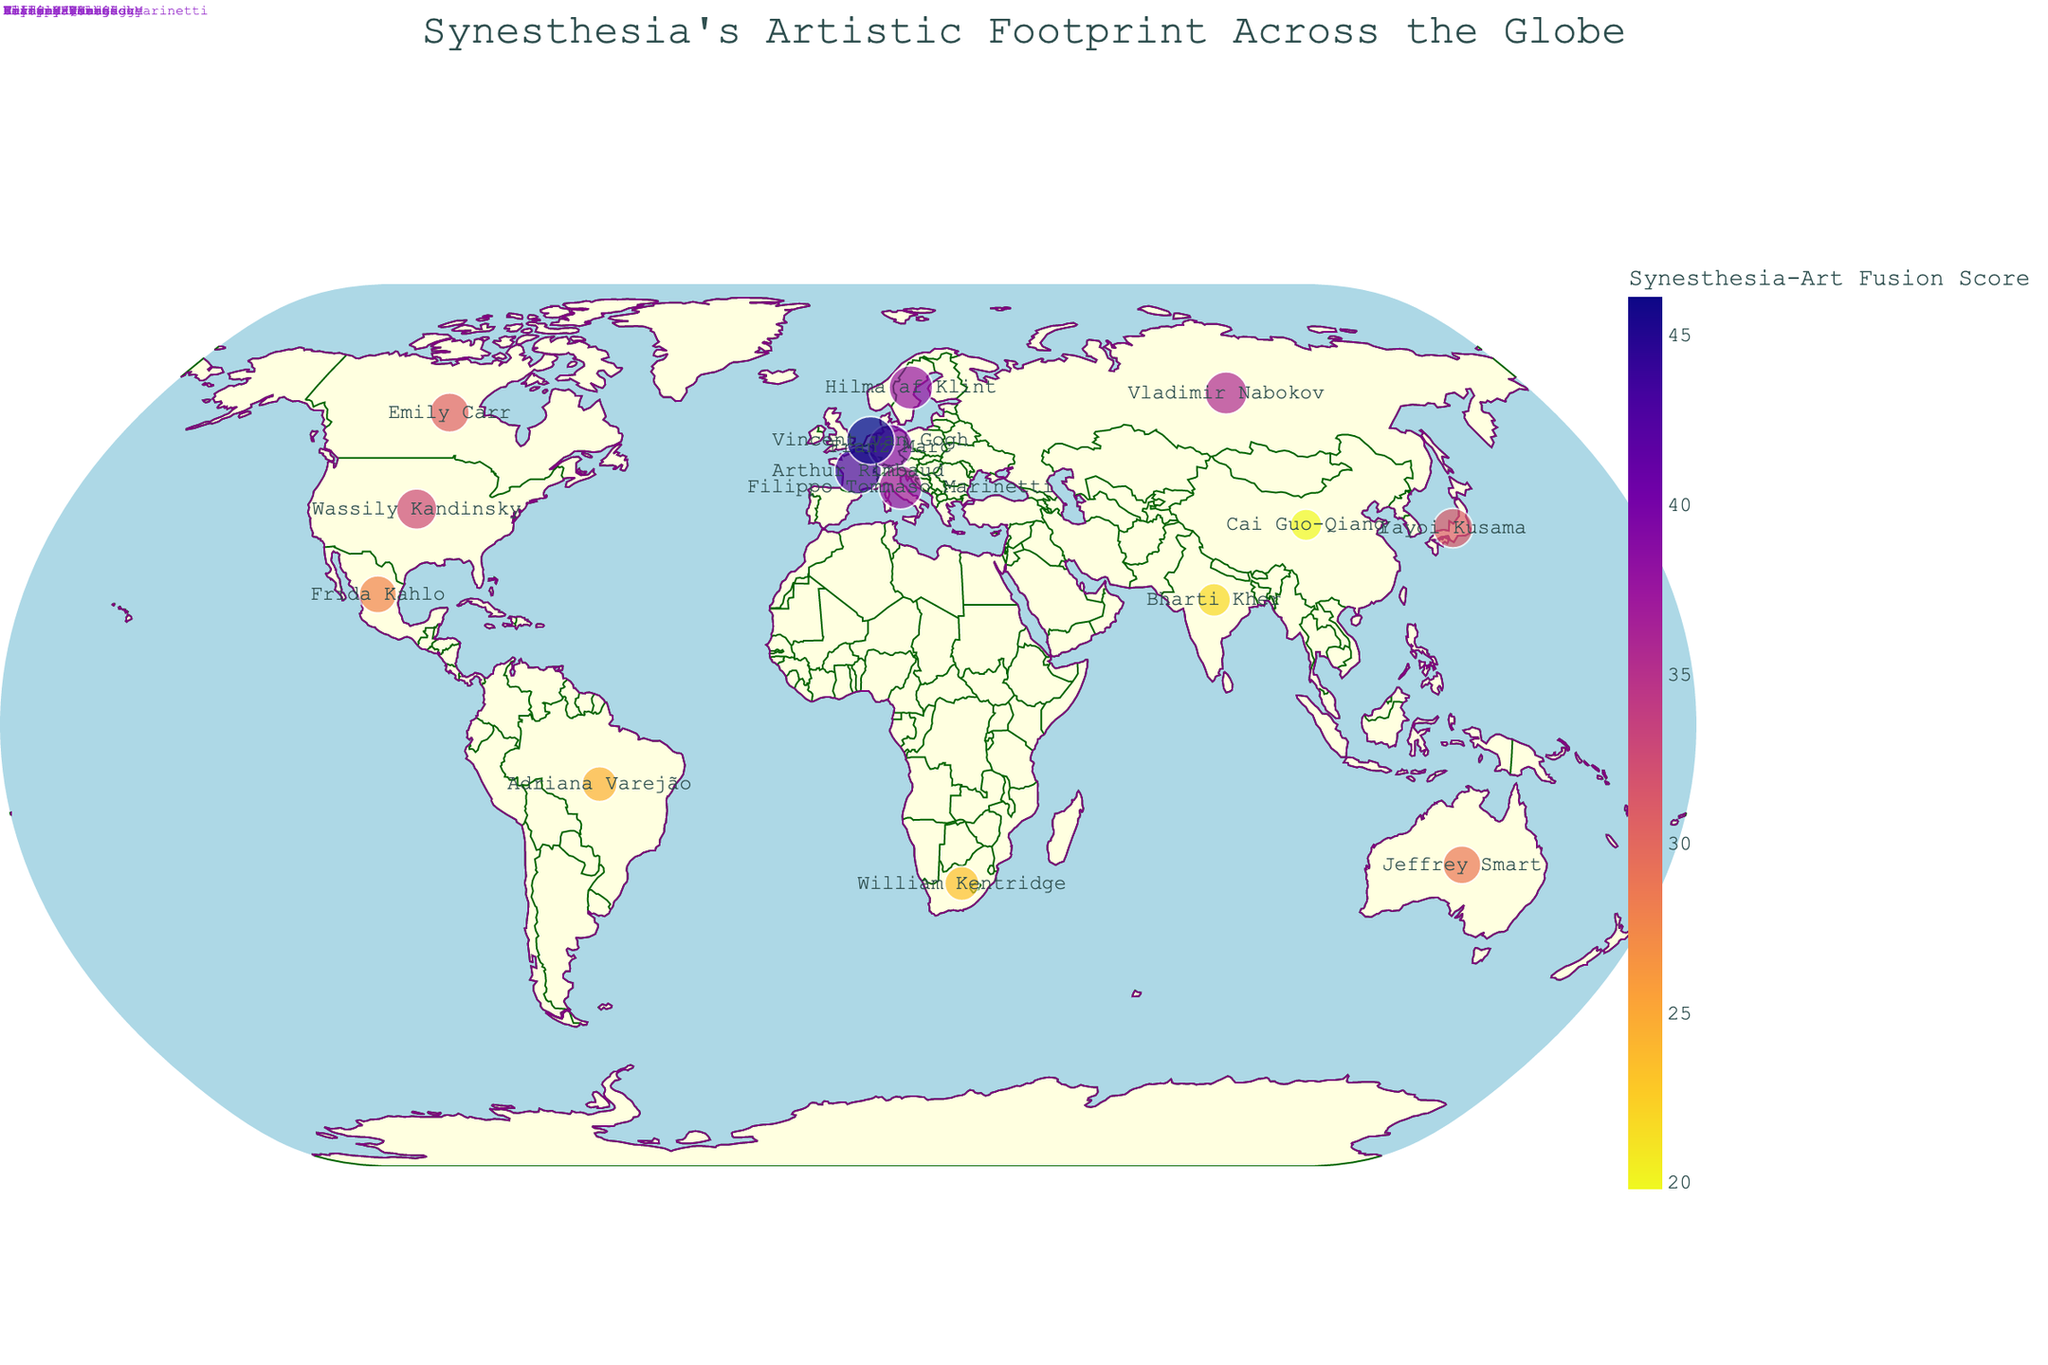What is the title of the figure? The title is typically displayed at the top of the geographic plot. It provides an overview of what the plot represents.
Answer: Synesthesia's Artistic Footprint Across the Globe Which country has the highest Synesthesia-Artistic Score? By observing the size and color of the points on the map, you can identify which country has the highest score. Larger and darker points indicate higher scores.
Answer: Netherlands Which country is represented by the artist Vincent van Gogh? Hovering over or observing the annotated text on the specific point representing a country, you can identify the notable artist linked to it.
Answer: Netherlands What is the Synesthesia-Artistic Score for France? You can determine this by locating France on the map and seeing the corresponding size and color of the point. The hover text can also provide this information.
Answer: 43.35 Compare the Synesthesia-Artistic Score of Brazil and Russia. Which country has a higher score? To compare, find both Brazil and Russia on the map and look at the respective point sizes and colors or use the hover text to find the exact scores.
Answer: Russia What colors are used to represent the Synesthesia-Artistic Score? Observing the color range and intensity on the map, you can see the colors used to represent various scores. The color bar legend can also help.
Answer: Multiple shades including purple to yellow How does the Synesthesia_Prevalence of Japan compare to that of China? Locate Japan and China on the map and review the hover text or annotations to determine and compare their Synesthesia_Prevalence values.
Answer: Japan has higher prevalence Which country has a notable artist named Wassily Kandinsky? Find the label or hover text indicating the artist's name to identify the corresponding country.
Answer: United States Is there a visible pattern or region with high Synesthesia-Artistic Scores? By looking at the map, visually identify if certain regions or clusters have larger and more intensely colored points, indicating higher scores.
Answer: Europe Calculate the average Synesthesia-Artistic Score for Germany, Sweden, and Italy. Locate each country on the map and gather their scores. Sum them up and divide by the number of countries: (39.2 + 37.92 + 37.35)/3.
Answer: 38.16 